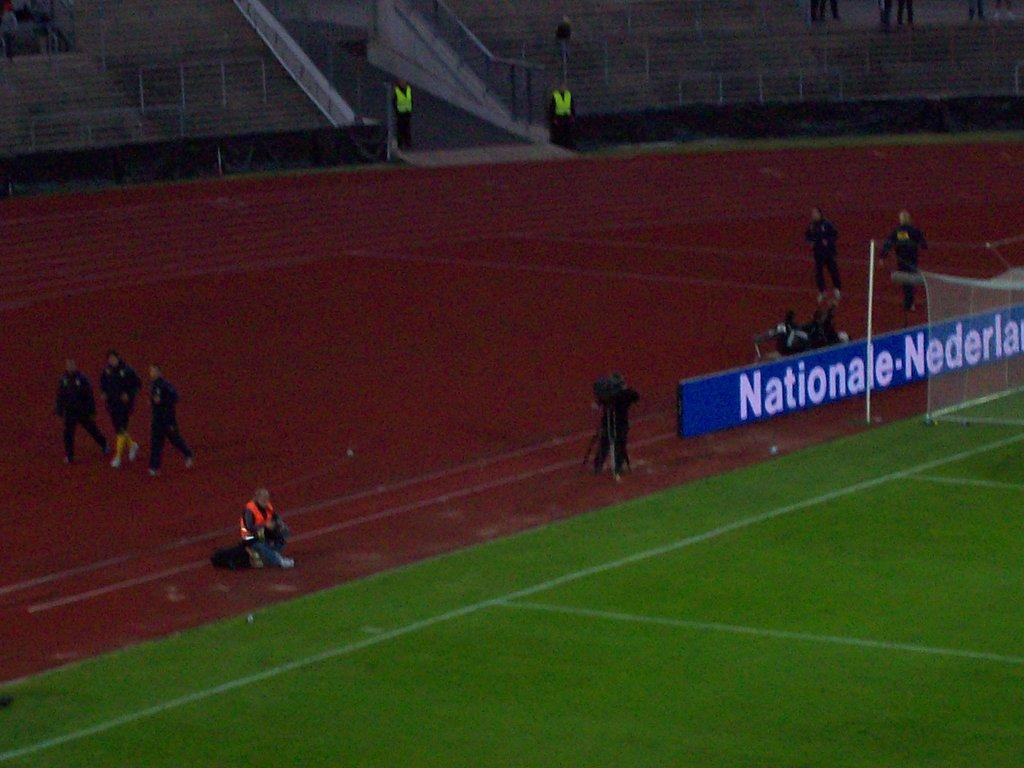<image>
Provide a brief description of the given image. a nationale ad on a wall and people standing around it 